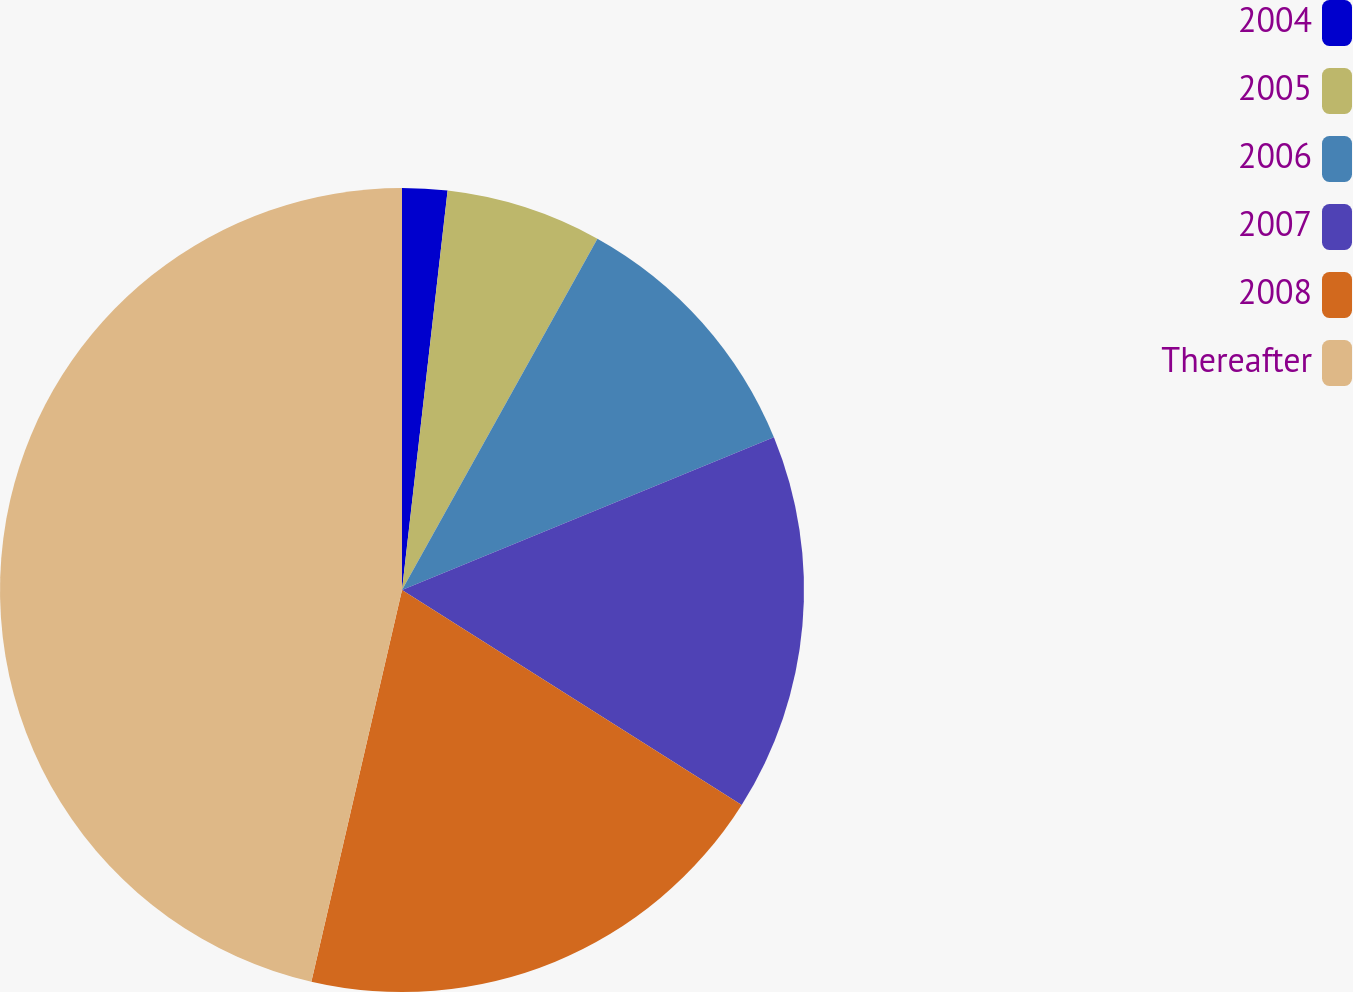Convert chart. <chart><loc_0><loc_0><loc_500><loc_500><pie_chart><fcel>2004<fcel>2005<fcel>2006<fcel>2007<fcel>2008<fcel>Thereafter<nl><fcel>1.81%<fcel>6.27%<fcel>10.72%<fcel>15.18%<fcel>19.64%<fcel>46.38%<nl></chart> 